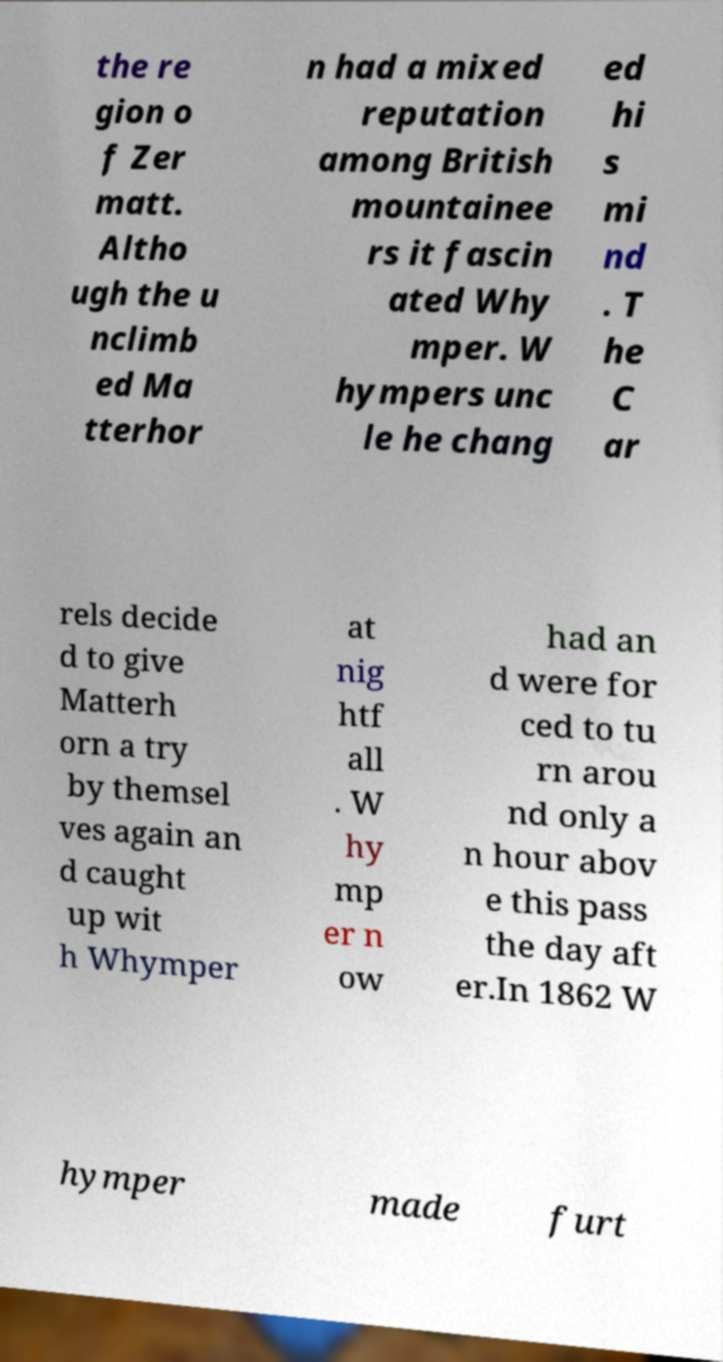Could you extract and type out the text from this image? the re gion o f Zer matt. Altho ugh the u nclimb ed Ma tterhor n had a mixed reputation among British mountainee rs it fascin ated Why mper. W hympers unc le he chang ed hi s mi nd . T he C ar rels decide d to give Matterh orn a try by themsel ves again an d caught up wit h Whymper at nig htf all . W hy mp er n ow had an d were for ced to tu rn arou nd only a n hour abov e this pass the day aft er.In 1862 W hymper made furt 